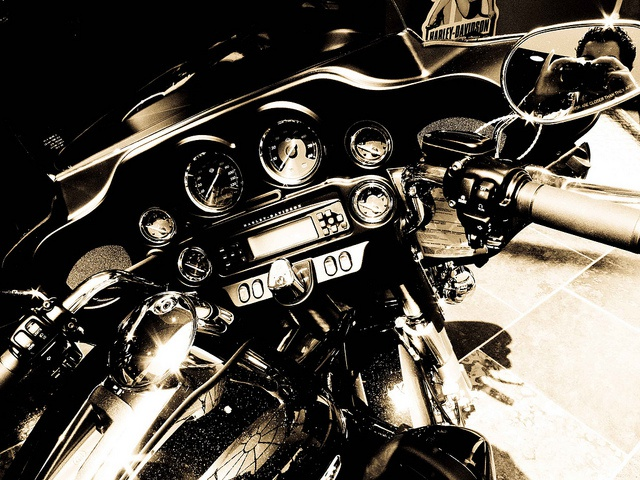Describe the objects in this image and their specific colors. I can see motorcycle in black, ivory, tan, and gray tones and people in black, gray, and ivory tones in this image. 